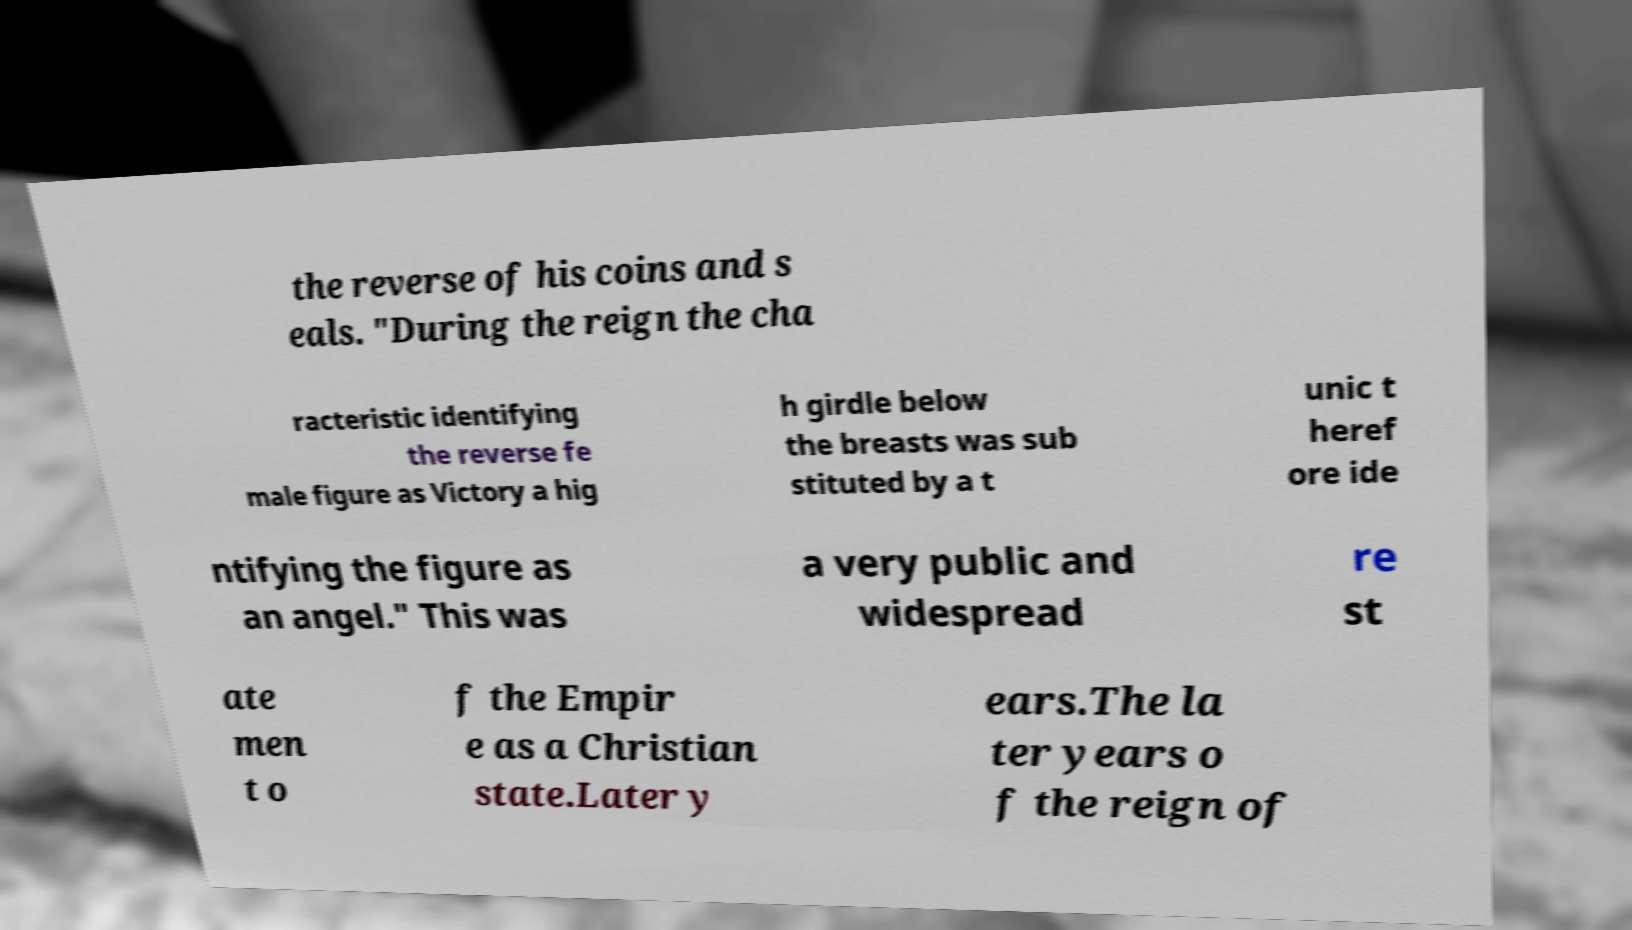Please read and relay the text visible in this image. What does it say? the reverse of his coins and s eals. "During the reign the cha racteristic identifying the reverse fe male figure as Victory a hig h girdle below the breasts was sub stituted by a t unic t heref ore ide ntifying the figure as an angel." This was a very public and widespread re st ate men t o f the Empir e as a Christian state.Later y ears.The la ter years o f the reign of 